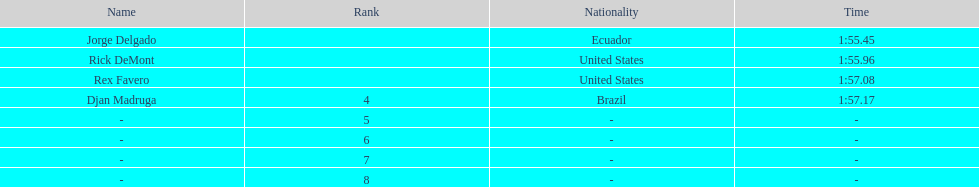Who was the last finisher from the us? Rex Favero. 